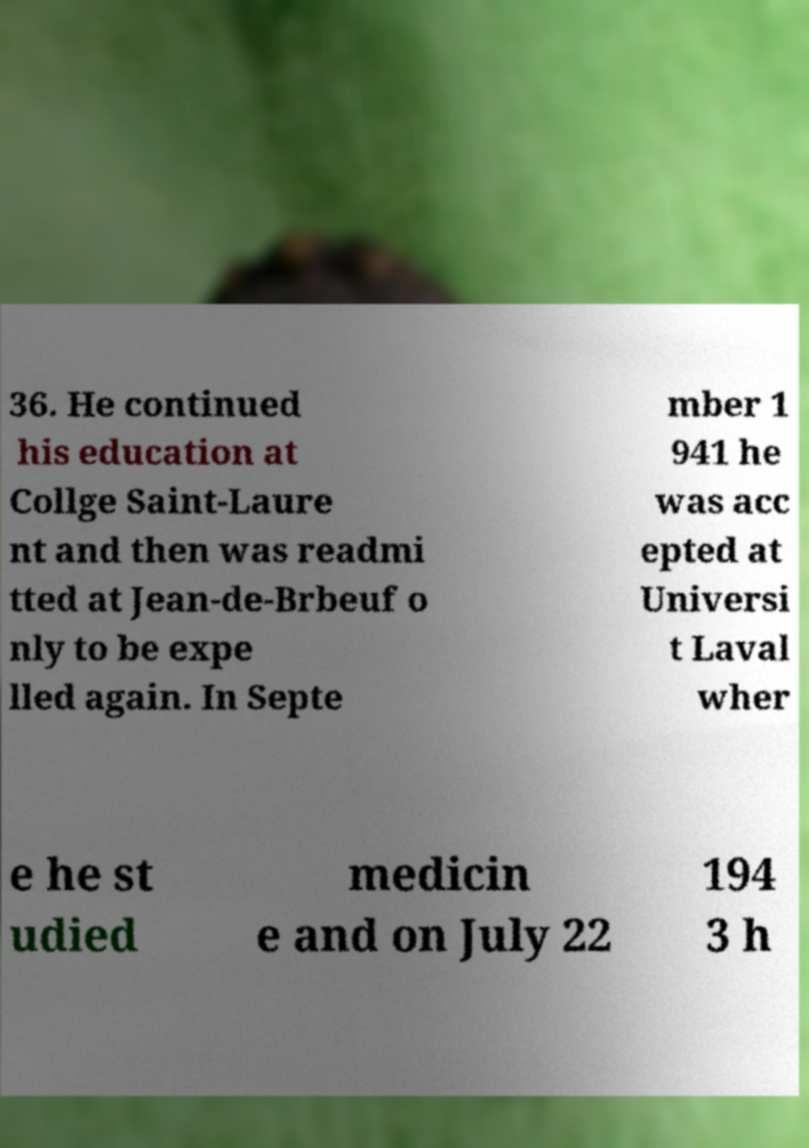I need the written content from this picture converted into text. Can you do that? 36. He continued his education at Collge Saint-Laure nt and then was readmi tted at Jean-de-Brbeuf o nly to be expe lled again. In Septe mber 1 941 he was acc epted at Universi t Laval wher e he st udied medicin e and on July 22 194 3 h 